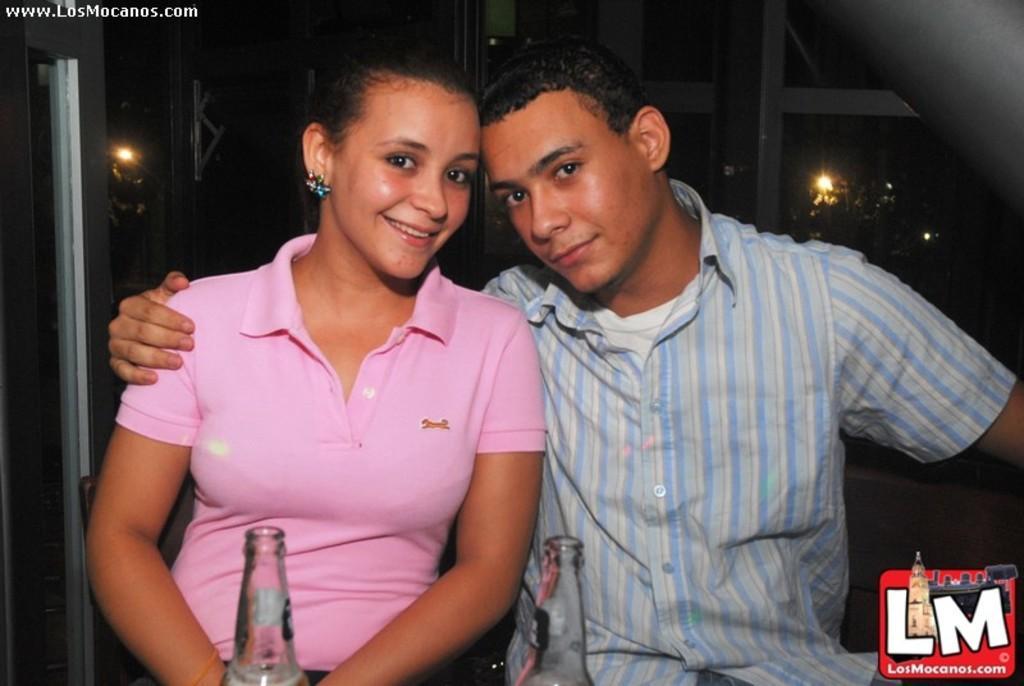Please provide a concise description of this image. In this image we can see two persons sitting and there are two bottles in front of them. 